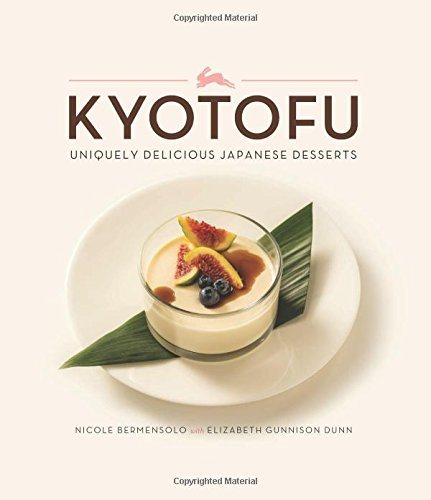Can you describe one of the recipes featured in this book? Certainly! One of the highlighted recipes is for 'Matcha-Glazed Tofu Doughnuts,' which combines the subtle flavors of matcha green tea with the richness of tofu to create a uniquely light yet indulgent dessert. 